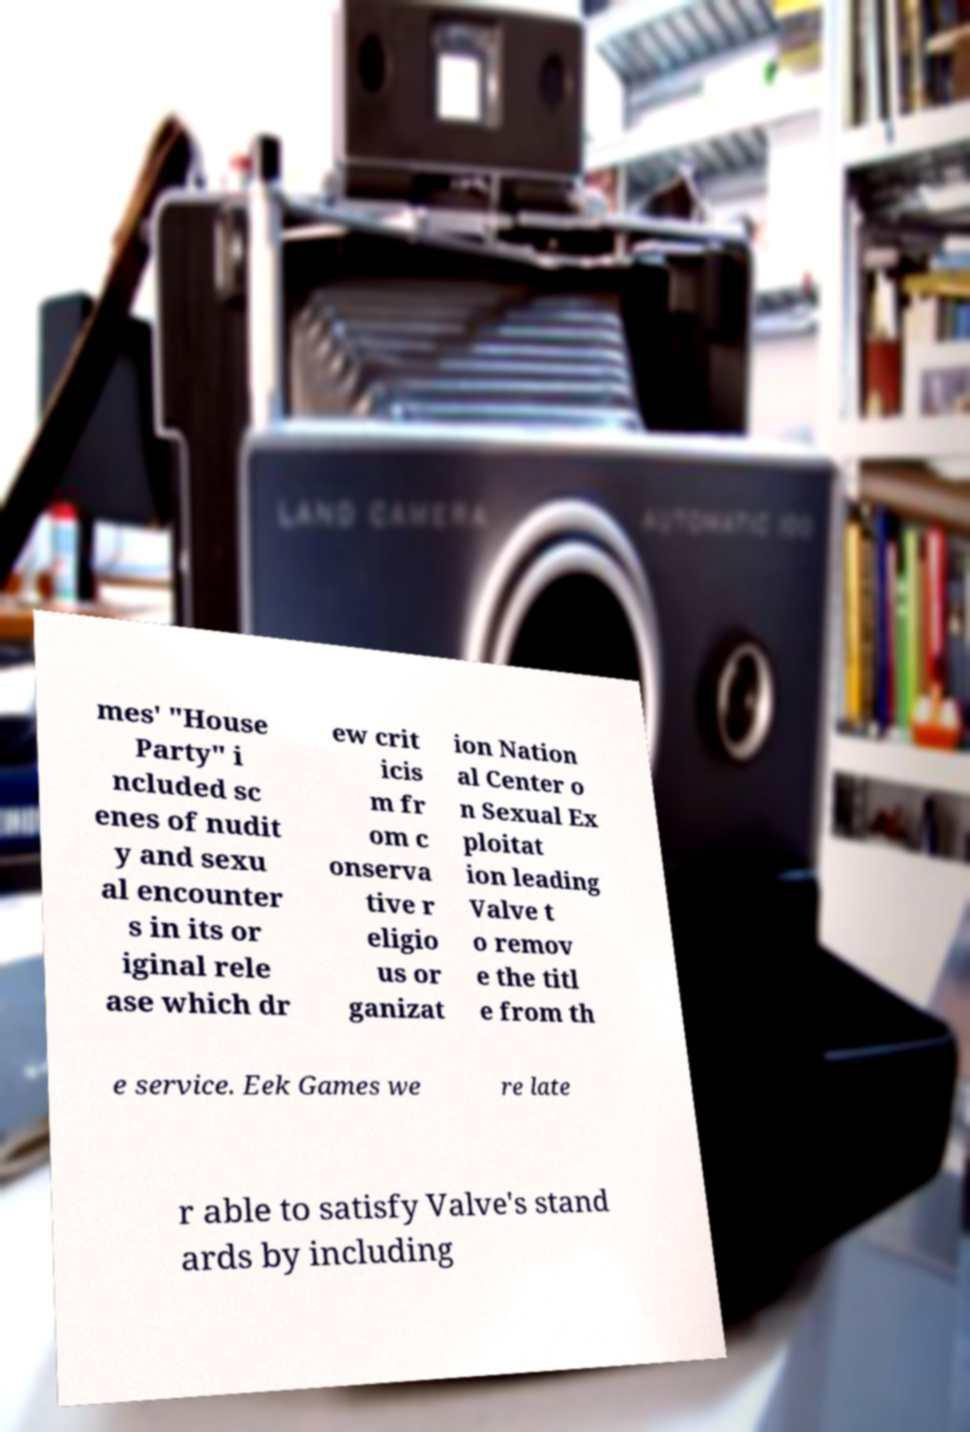Can you read and provide the text displayed in the image?This photo seems to have some interesting text. Can you extract and type it out for me? mes' "House Party" i ncluded sc enes of nudit y and sexu al encounter s in its or iginal rele ase which dr ew crit icis m fr om c onserva tive r eligio us or ganizat ion Nation al Center o n Sexual Ex ploitat ion leading Valve t o remov e the titl e from th e service. Eek Games we re late r able to satisfy Valve's stand ards by including 